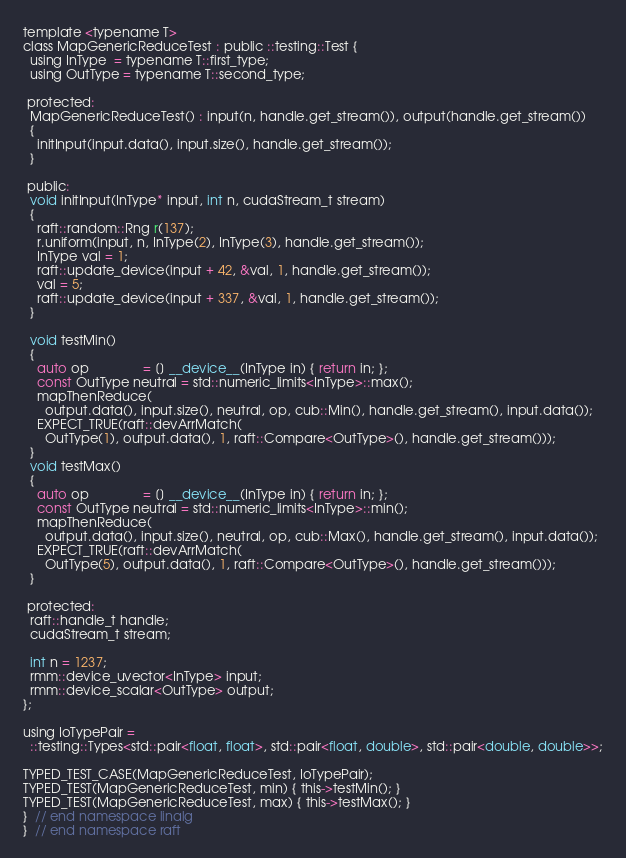<code> <loc_0><loc_0><loc_500><loc_500><_Cuda_>template <typename T>
class MapGenericReduceTest : public ::testing::Test {
  using InType  = typename T::first_type;
  using OutType = typename T::second_type;

 protected:
  MapGenericReduceTest() : input(n, handle.get_stream()), output(handle.get_stream())
  {
    initInput(input.data(), input.size(), handle.get_stream());
  }

 public:
  void initInput(InType* input, int n, cudaStream_t stream)
  {
    raft::random::Rng r(137);
    r.uniform(input, n, InType(2), InType(3), handle.get_stream());
    InType val = 1;
    raft::update_device(input + 42, &val, 1, handle.get_stream());
    val = 5;
    raft::update_device(input + 337, &val, 1, handle.get_stream());
  }

  void testMin()
  {
    auto op               = [] __device__(InType in) { return in; };
    const OutType neutral = std::numeric_limits<InType>::max();
    mapThenReduce(
      output.data(), input.size(), neutral, op, cub::Min(), handle.get_stream(), input.data());
    EXPECT_TRUE(raft::devArrMatch(
      OutType(1), output.data(), 1, raft::Compare<OutType>(), handle.get_stream()));
  }
  void testMax()
  {
    auto op               = [] __device__(InType in) { return in; };
    const OutType neutral = std::numeric_limits<InType>::min();
    mapThenReduce(
      output.data(), input.size(), neutral, op, cub::Max(), handle.get_stream(), input.data());
    EXPECT_TRUE(raft::devArrMatch(
      OutType(5), output.data(), 1, raft::Compare<OutType>(), handle.get_stream()));
  }

 protected:
  raft::handle_t handle;
  cudaStream_t stream;

  int n = 1237;
  rmm::device_uvector<InType> input;
  rmm::device_scalar<OutType> output;
};

using IoTypePair =
  ::testing::Types<std::pair<float, float>, std::pair<float, double>, std::pair<double, double>>;

TYPED_TEST_CASE(MapGenericReduceTest, IoTypePair);
TYPED_TEST(MapGenericReduceTest, min) { this->testMin(); }
TYPED_TEST(MapGenericReduceTest, max) { this->testMax(); }
}  // end namespace linalg
}  // end namespace raft
</code> 